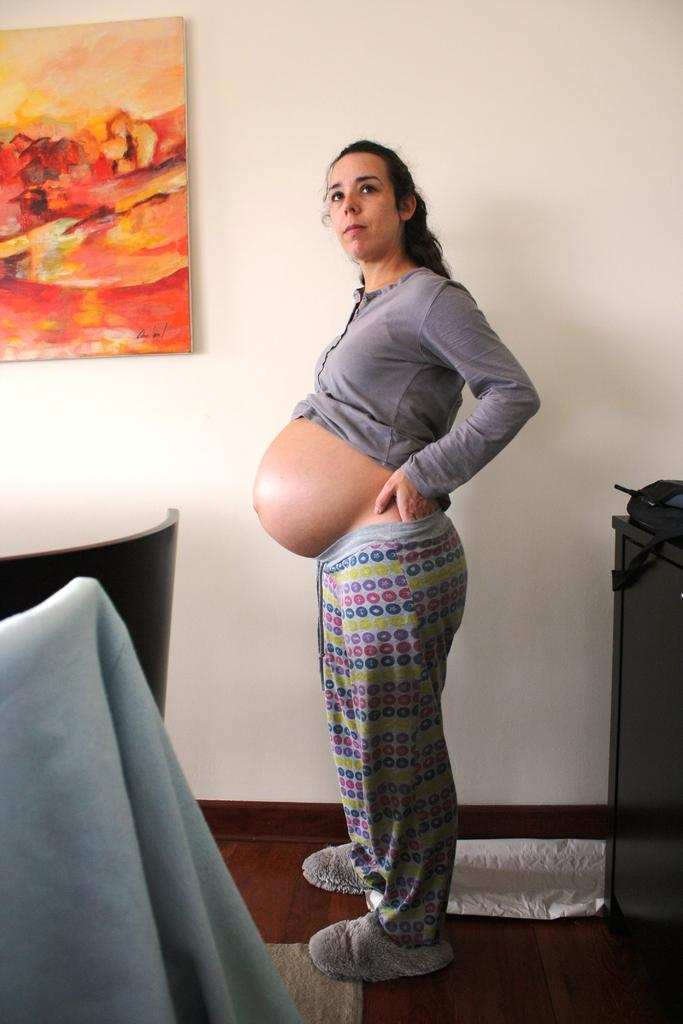Who is present in the image? There is a woman in the image. What is the woman wearing? The woman is wearing a grey dress. Where is the woman standing? The woman is standing on the floor. What can be seen on the wall in the image? There is a cream-colored wall in the image, and a photo frame is attached to it. What other objects are visible in the image? There are other objects visible in the image, but their specific details are not mentioned in the provided facts. What type of food is the woman eating with a fork in the image? There is no fork present in the image, and the woman's actions are not described in the provided facts. 